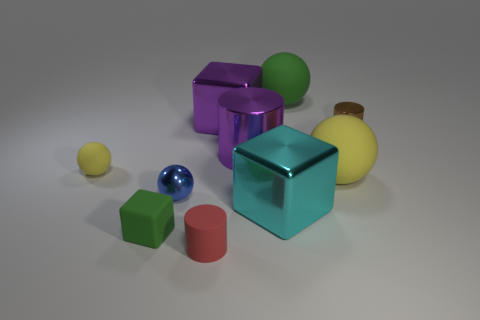Subtract all cylinders. How many objects are left? 7 Subtract all small shiny cylinders. Subtract all big rubber spheres. How many objects are left? 7 Add 6 big cyan objects. How many big cyan objects are left? 7 Add 2 tiny gray spheres. How many tiny gray spheres exist? 2 Subtract 1 purple blocks. How many objects are left? 9 